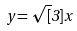Convert formula to latex. <formula><loc_0><loc_0><loc_500><loc_500>y = \sqrt { [ } 3 ] { x }</formula> 